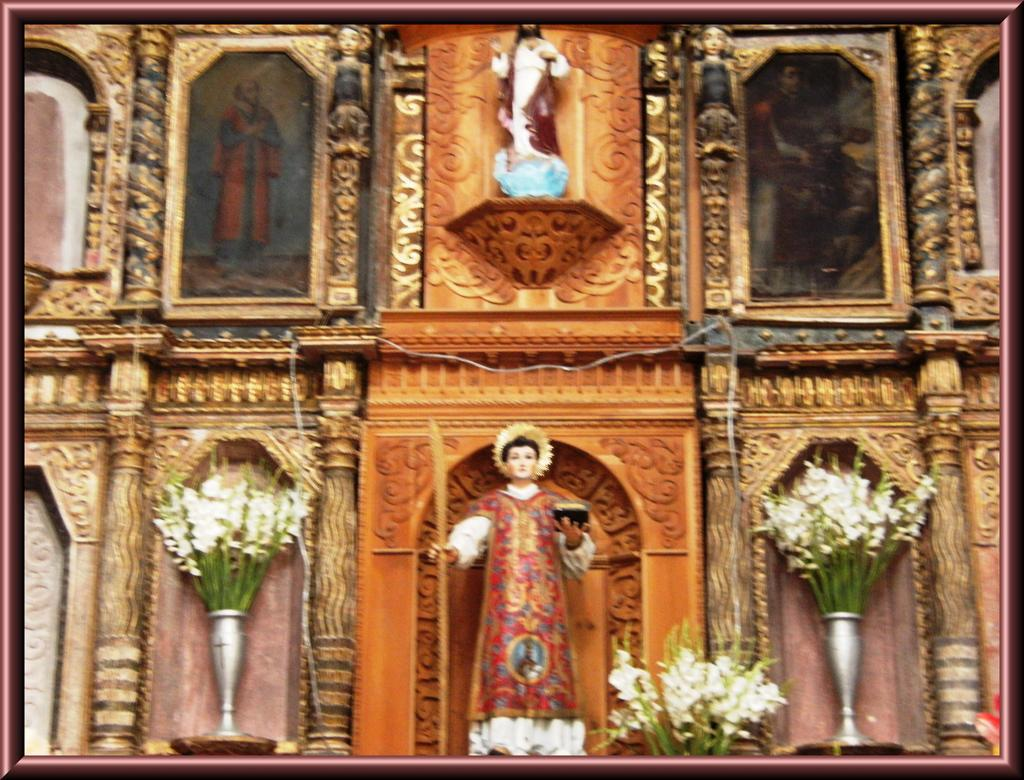What type of artwork can be seen in the image? There are sculptures in the image. What other elements are present in the image besides the sculptures? There are flowers and frames on the wall in the image. How many coils are visible in the image? There are no coils present in the image. What type of stage can be seen in the image? There is no stage present in the image. 